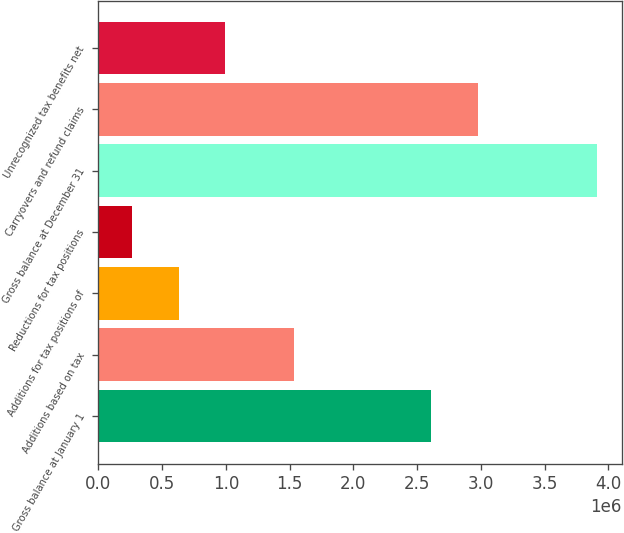Convert chart. <chart><loc_0><loc_0><loc_500><loc_500><bar_chart><fcel>Gross balance at January 1<fcel>Additions based on tax<fcel>Additions for tax positions of<fcel>Reductions for tax positions<fcel>Gross balance at December 31<fcel>Carryovers and refund claims<fcel>Unrecognized tax benefits net<nl><fcel>2.61158e+06<fcel>1.53278e+06<fcel>630073<fcel>265653<fcel>3.90986e+06<fcel>2.97601e+06<fcel>994493<nl></chart> 